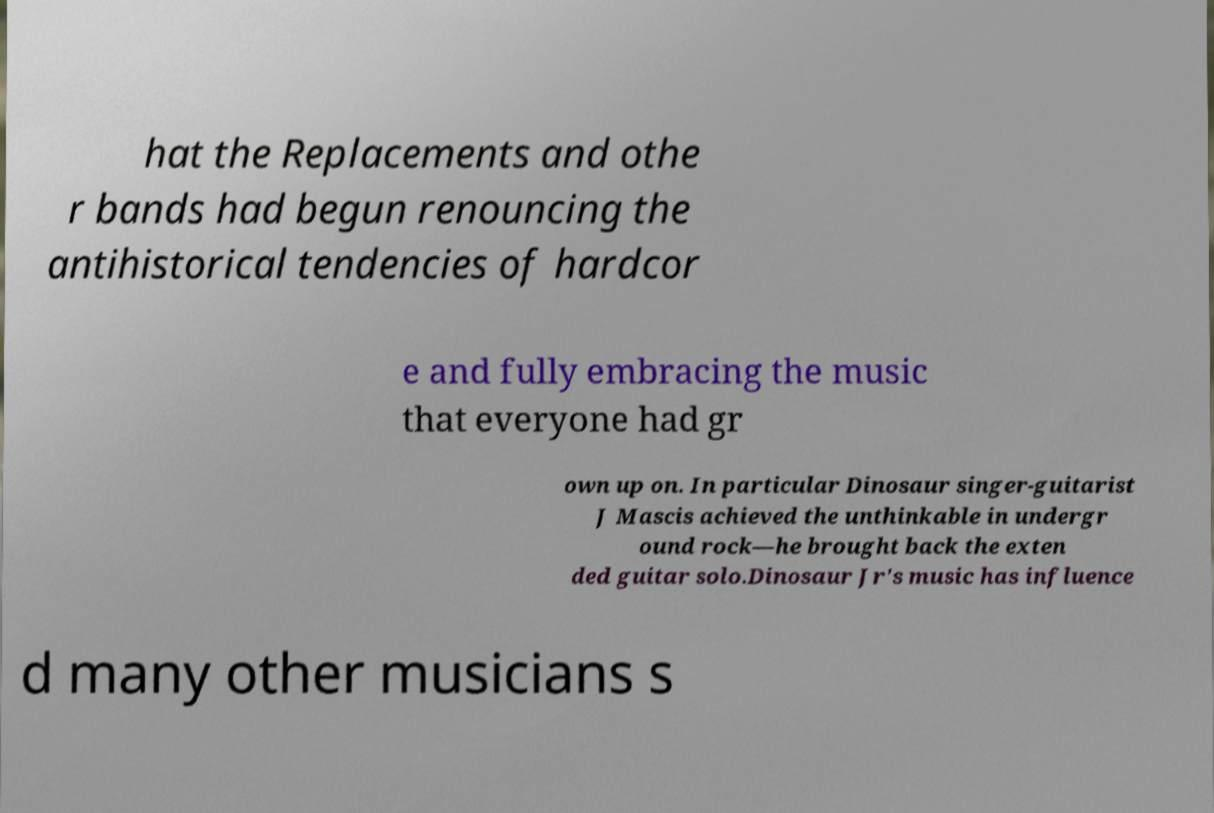Can you accurately transcribe the text from the provided image for me? hat the Replacements and othe r bands had begun renouncing the antihistorical tendencies of hardcor e and fully embracing the music that everyone had gr own up on. In particular Dinosaur singer-guitarist J Mascis achieved the unthinkable in undergr ound rock—he brought back the exten ded guitar solo.Dinosaur Jr's music has influence d many other musicians s 